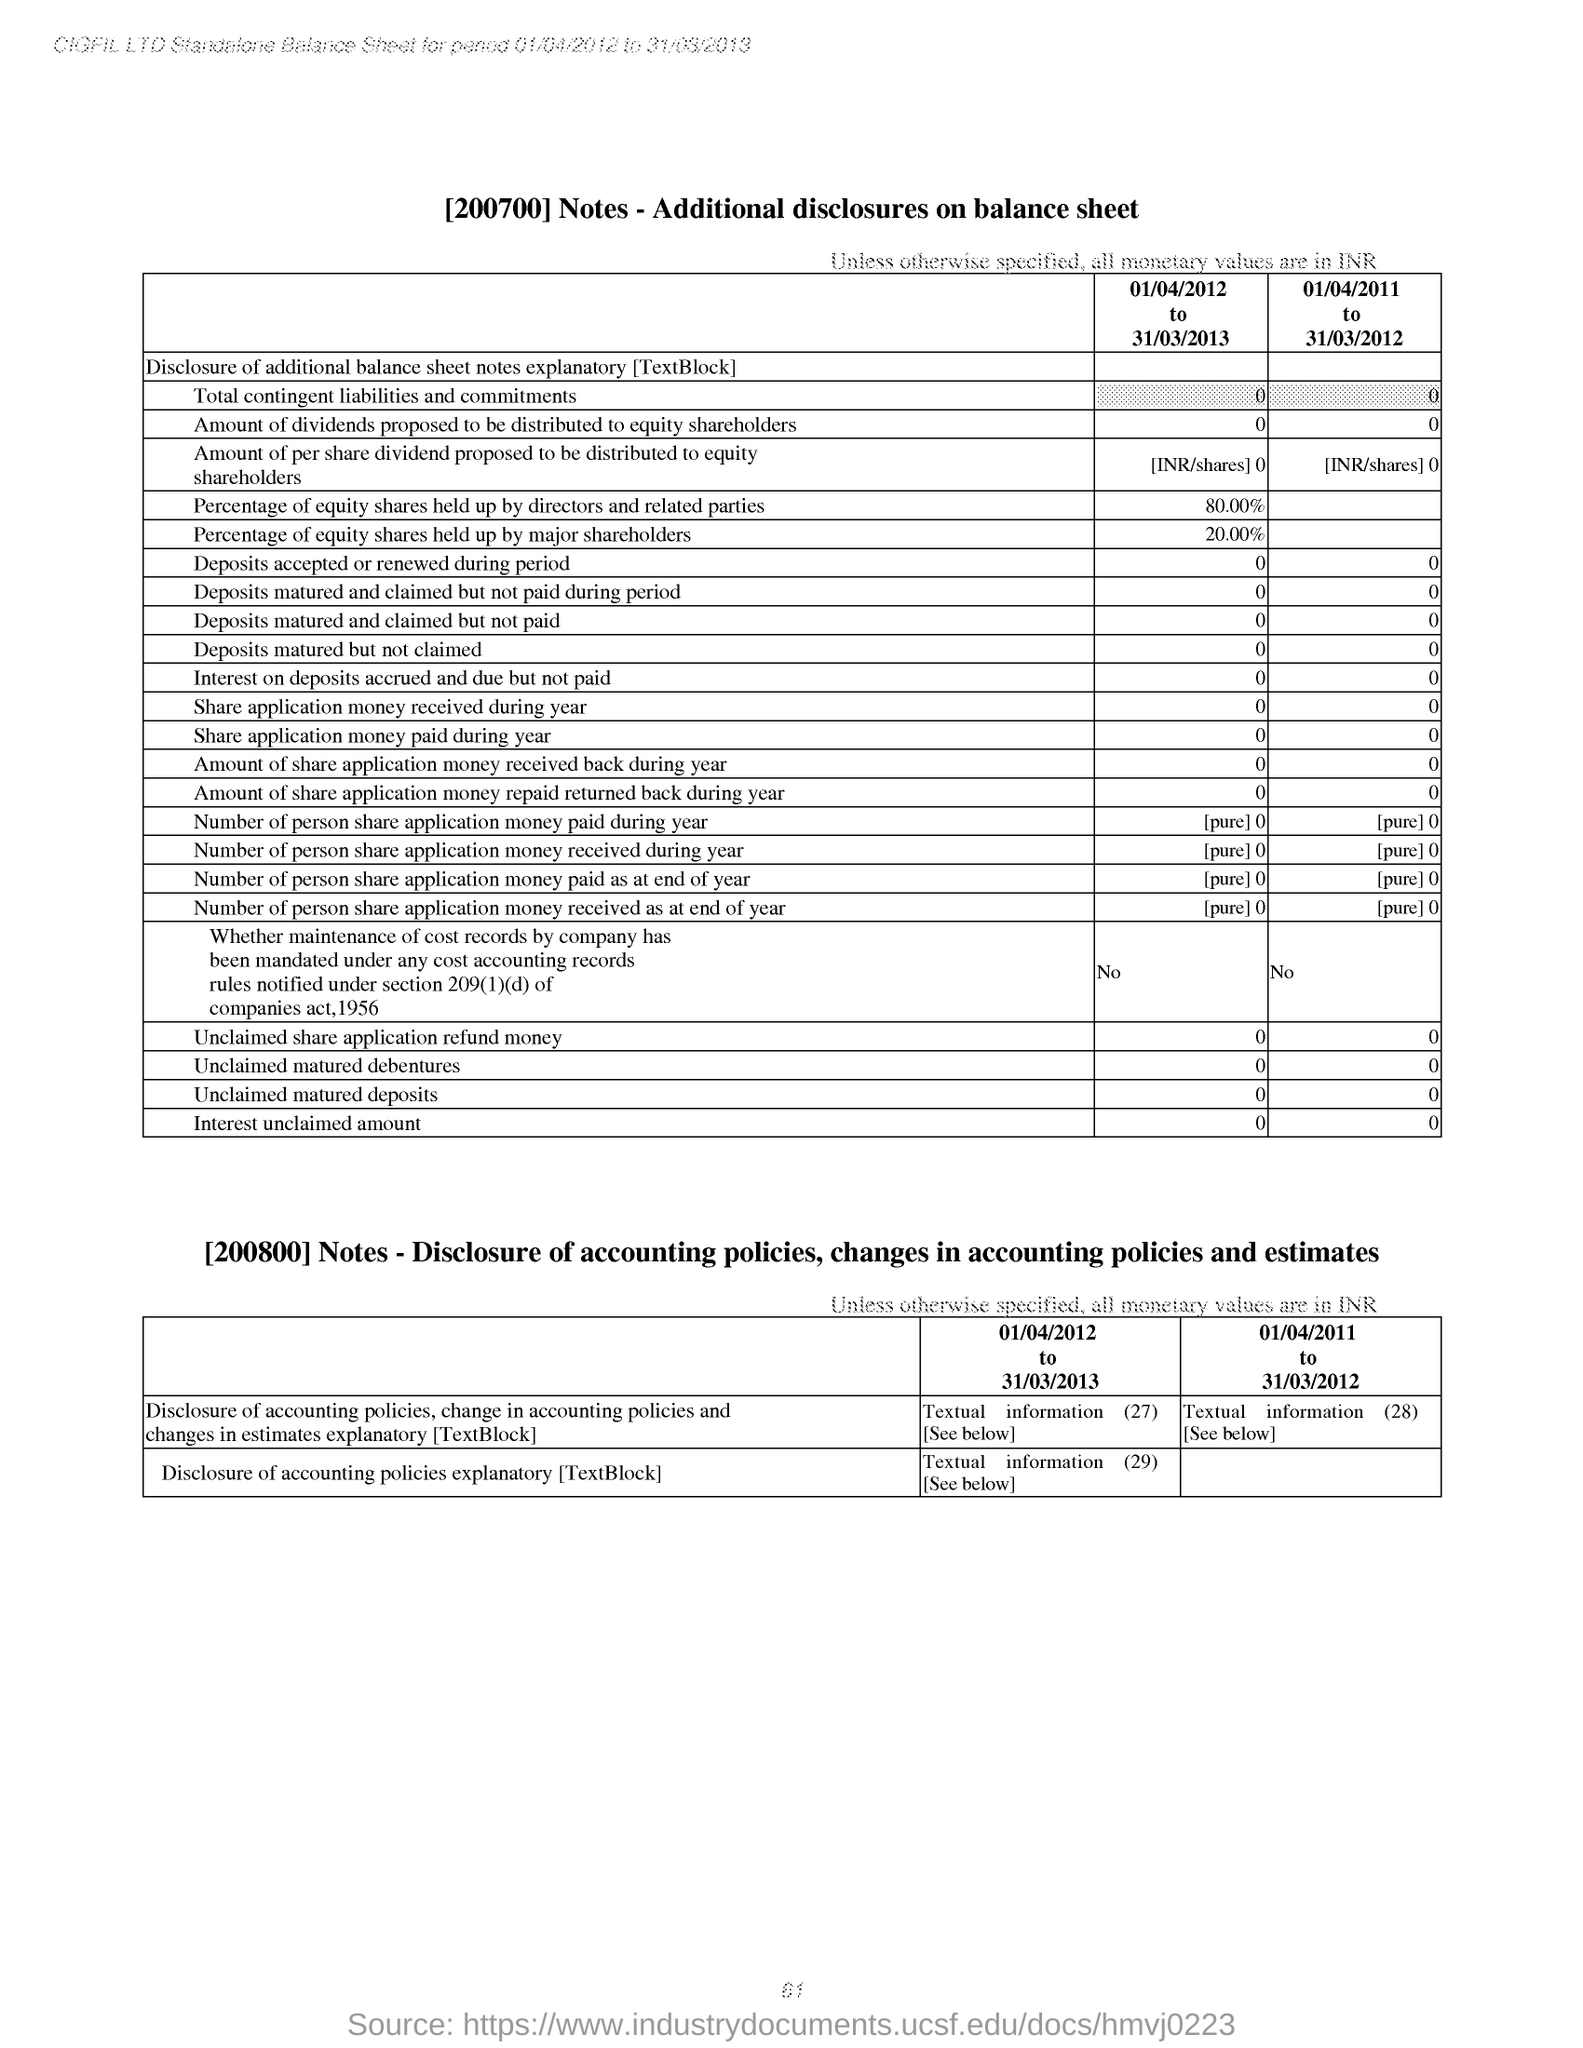Highlight a few significant elements in this photo. The title of the first table is 'Notes - Additional disclosures on balance sheet.' [200700] As of April 1, 2012, to March 31, 2013, the major shareholders held 20% of equity shares. 